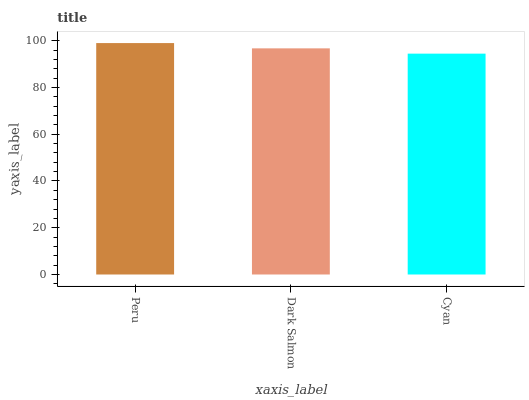Is Cyan the minimum?
Answer yes or no. Yes. Is Peru the maximum?
Answer yes or no. Yes. Is Dark Salmon the minimum?
Answer yes or no. No. Is Dark Salmon the maximum?
Answer yes or no. No. Is Peru greater than Dark Salmon?
Answer yes or no. Yes. Is Dark Salmon less than Peru?
Answer yes or no. Yes. Is Dark Salmon greater than Peru?
Answer yes or no. No. Is Peru less than Dark Salmon?
Answer yes or no. No. Is Dark Salmon the high median?
Answer yes or no. Yes. Is Dark Salmon the low median?
Answer yes or no. Yes. Is Peru the high median?
Answer yes or no. No. Is Peru the low median?
Answer yes or no. No. 